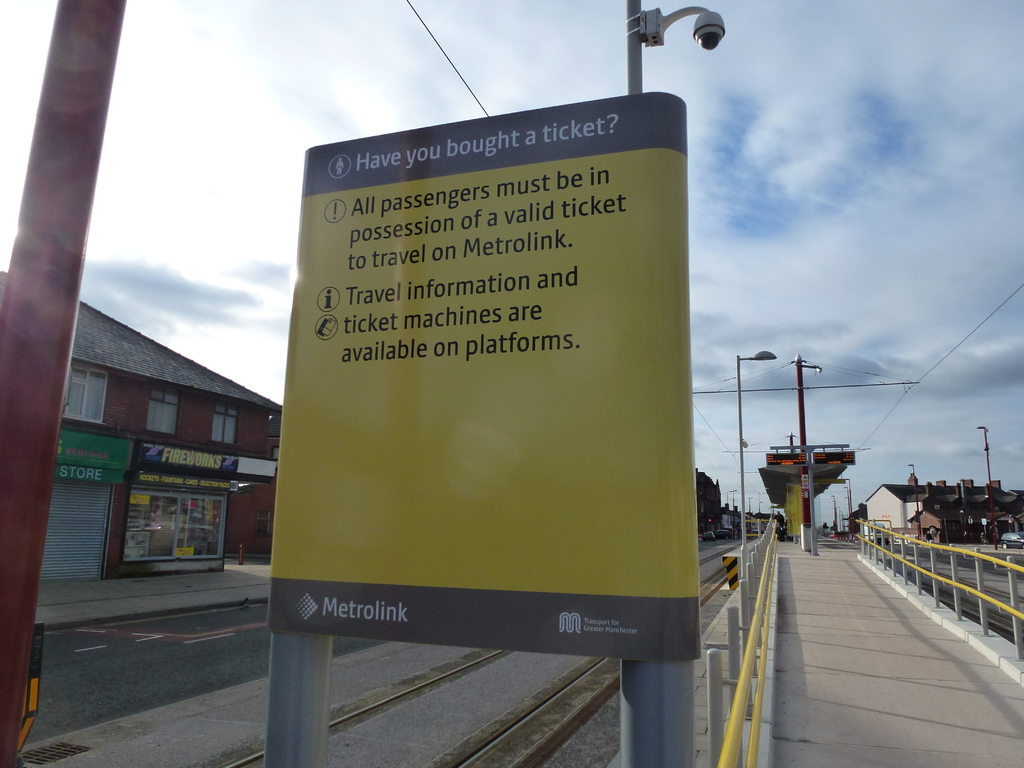What's happening in the scene? The image showcases a yellow informational sign at a Metrolink tram station, vividly reminding passengers: 'Have you bought a ticket? All passengers must be in possession of a valid ticket to travel on Metrolink.' This directive highlights necessary compliance for travel, supplemented by advice that travel information and ticket machines are accessible on the platforms. The sign, mounted on a robust gray pole, stands against a backdrop of a busy street lined with varied store fronts and a clear sky, illustrating a typical bustling day around the transport hub. 